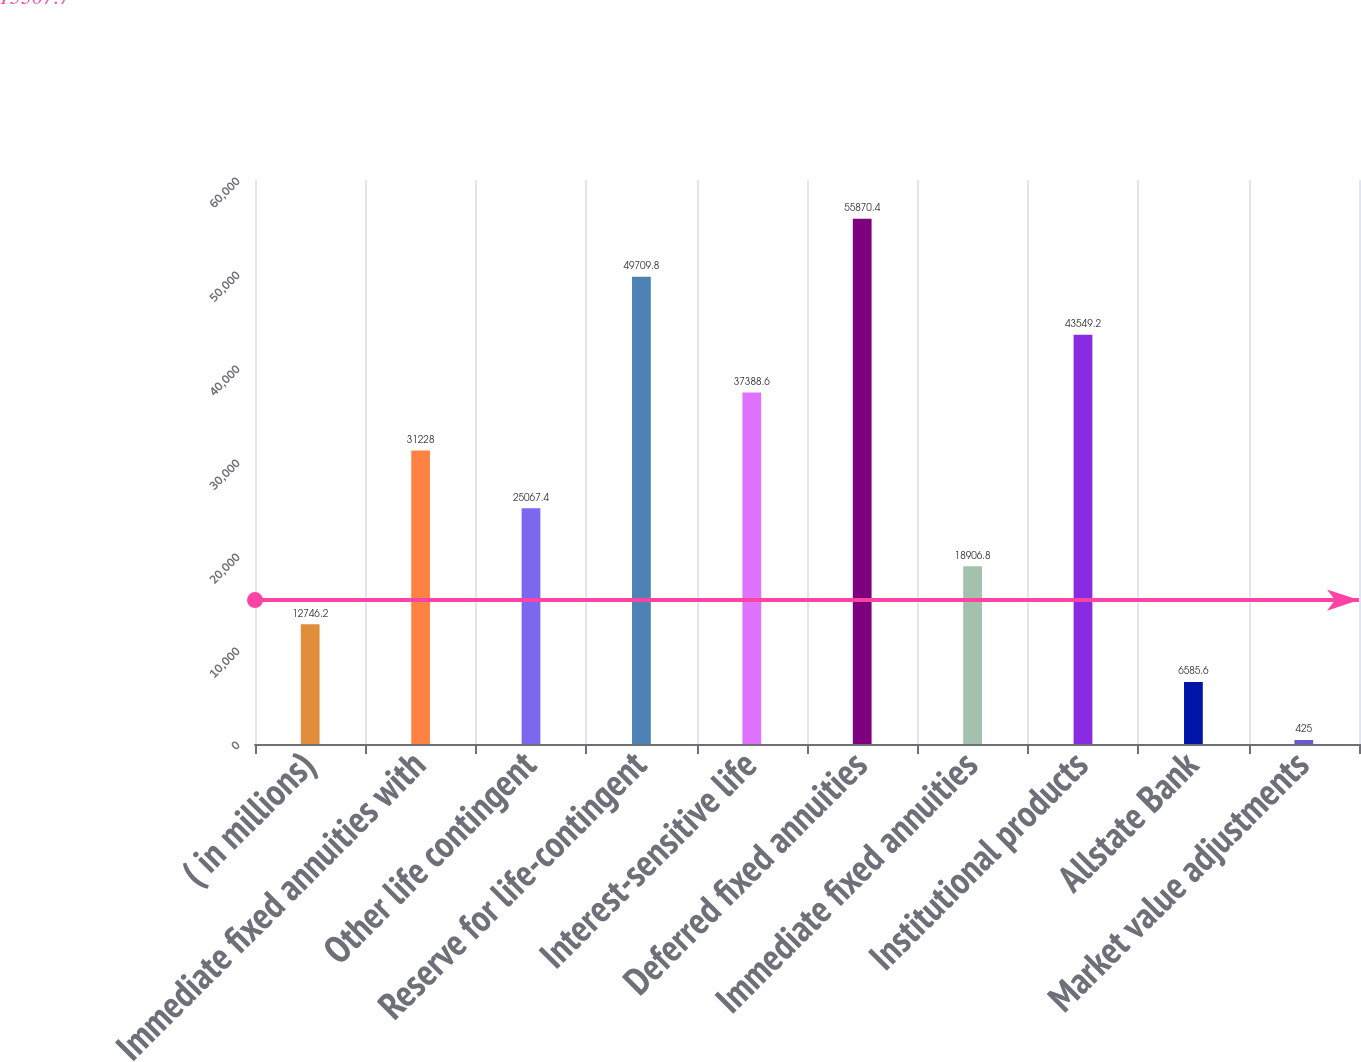<chart> <loc_0><loc_0><loc_500><loc_500><bar_chart><fcel>( in millions)<fcel>Immediate fixed annuities with<fcel>Other life contingent<fcel>Reserve for life-contingent<fcel>Interest-sensitive life<fcel>Deferred fixed annuities<fcel>Immediate fixed annuities<fcel>Institutional products<fcel>Allstate Bank<fcel>Market value adjustments<nl><fcel>12746.2<fcel>31228<fcel>25067.4<fcel>49709.8<fcel>37388.6<fcel>55870.4<fcel>18906.8<fcel>43549.2<fcel>6585.6<fcel>425<nl></chart> 